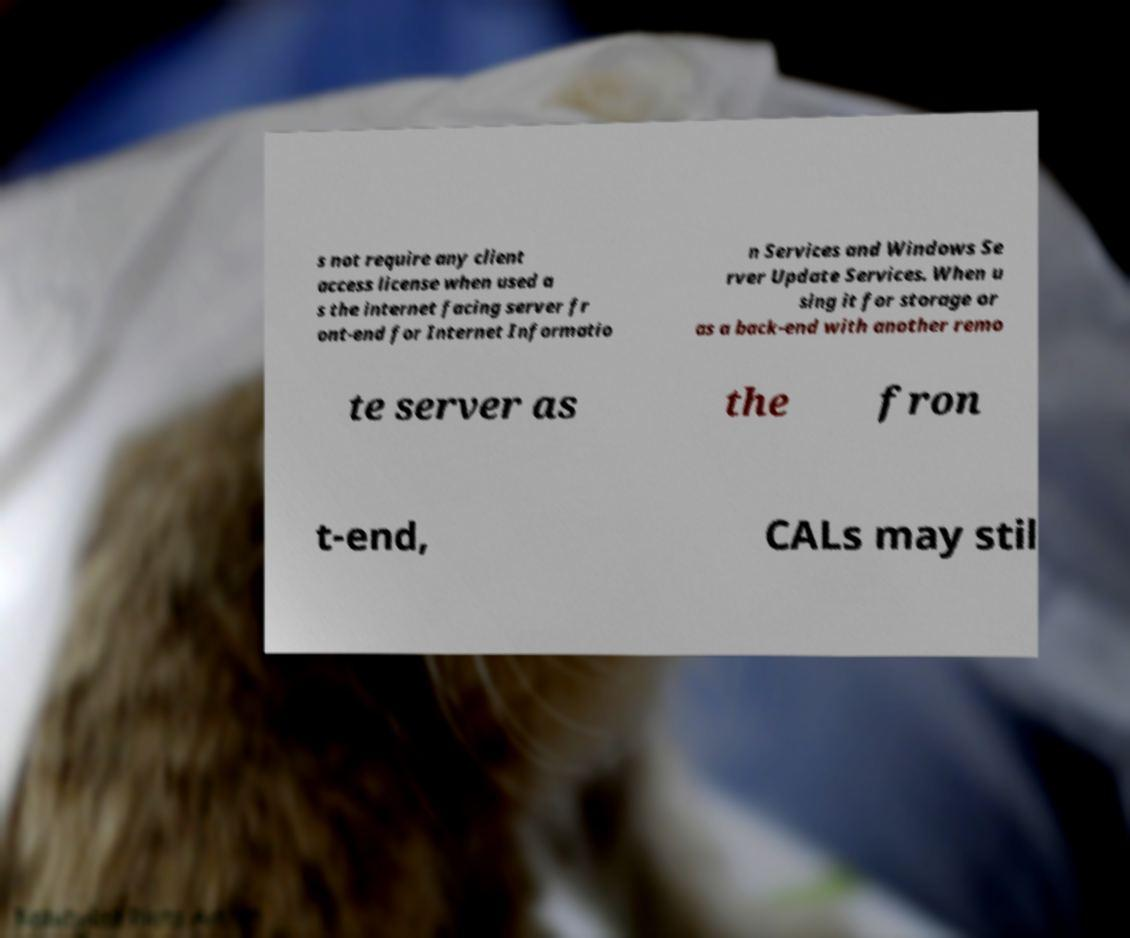For documentation purposes, I need the text within this image transcribed. Could you provide that? s not require any client access license when used a s the internet facing server fr ont-end for Internet Informatio n Services and Windows Se rver Update Services. When u sing it for storage or as a back-end with another remo te server as the fron t-end, CALs may stil 